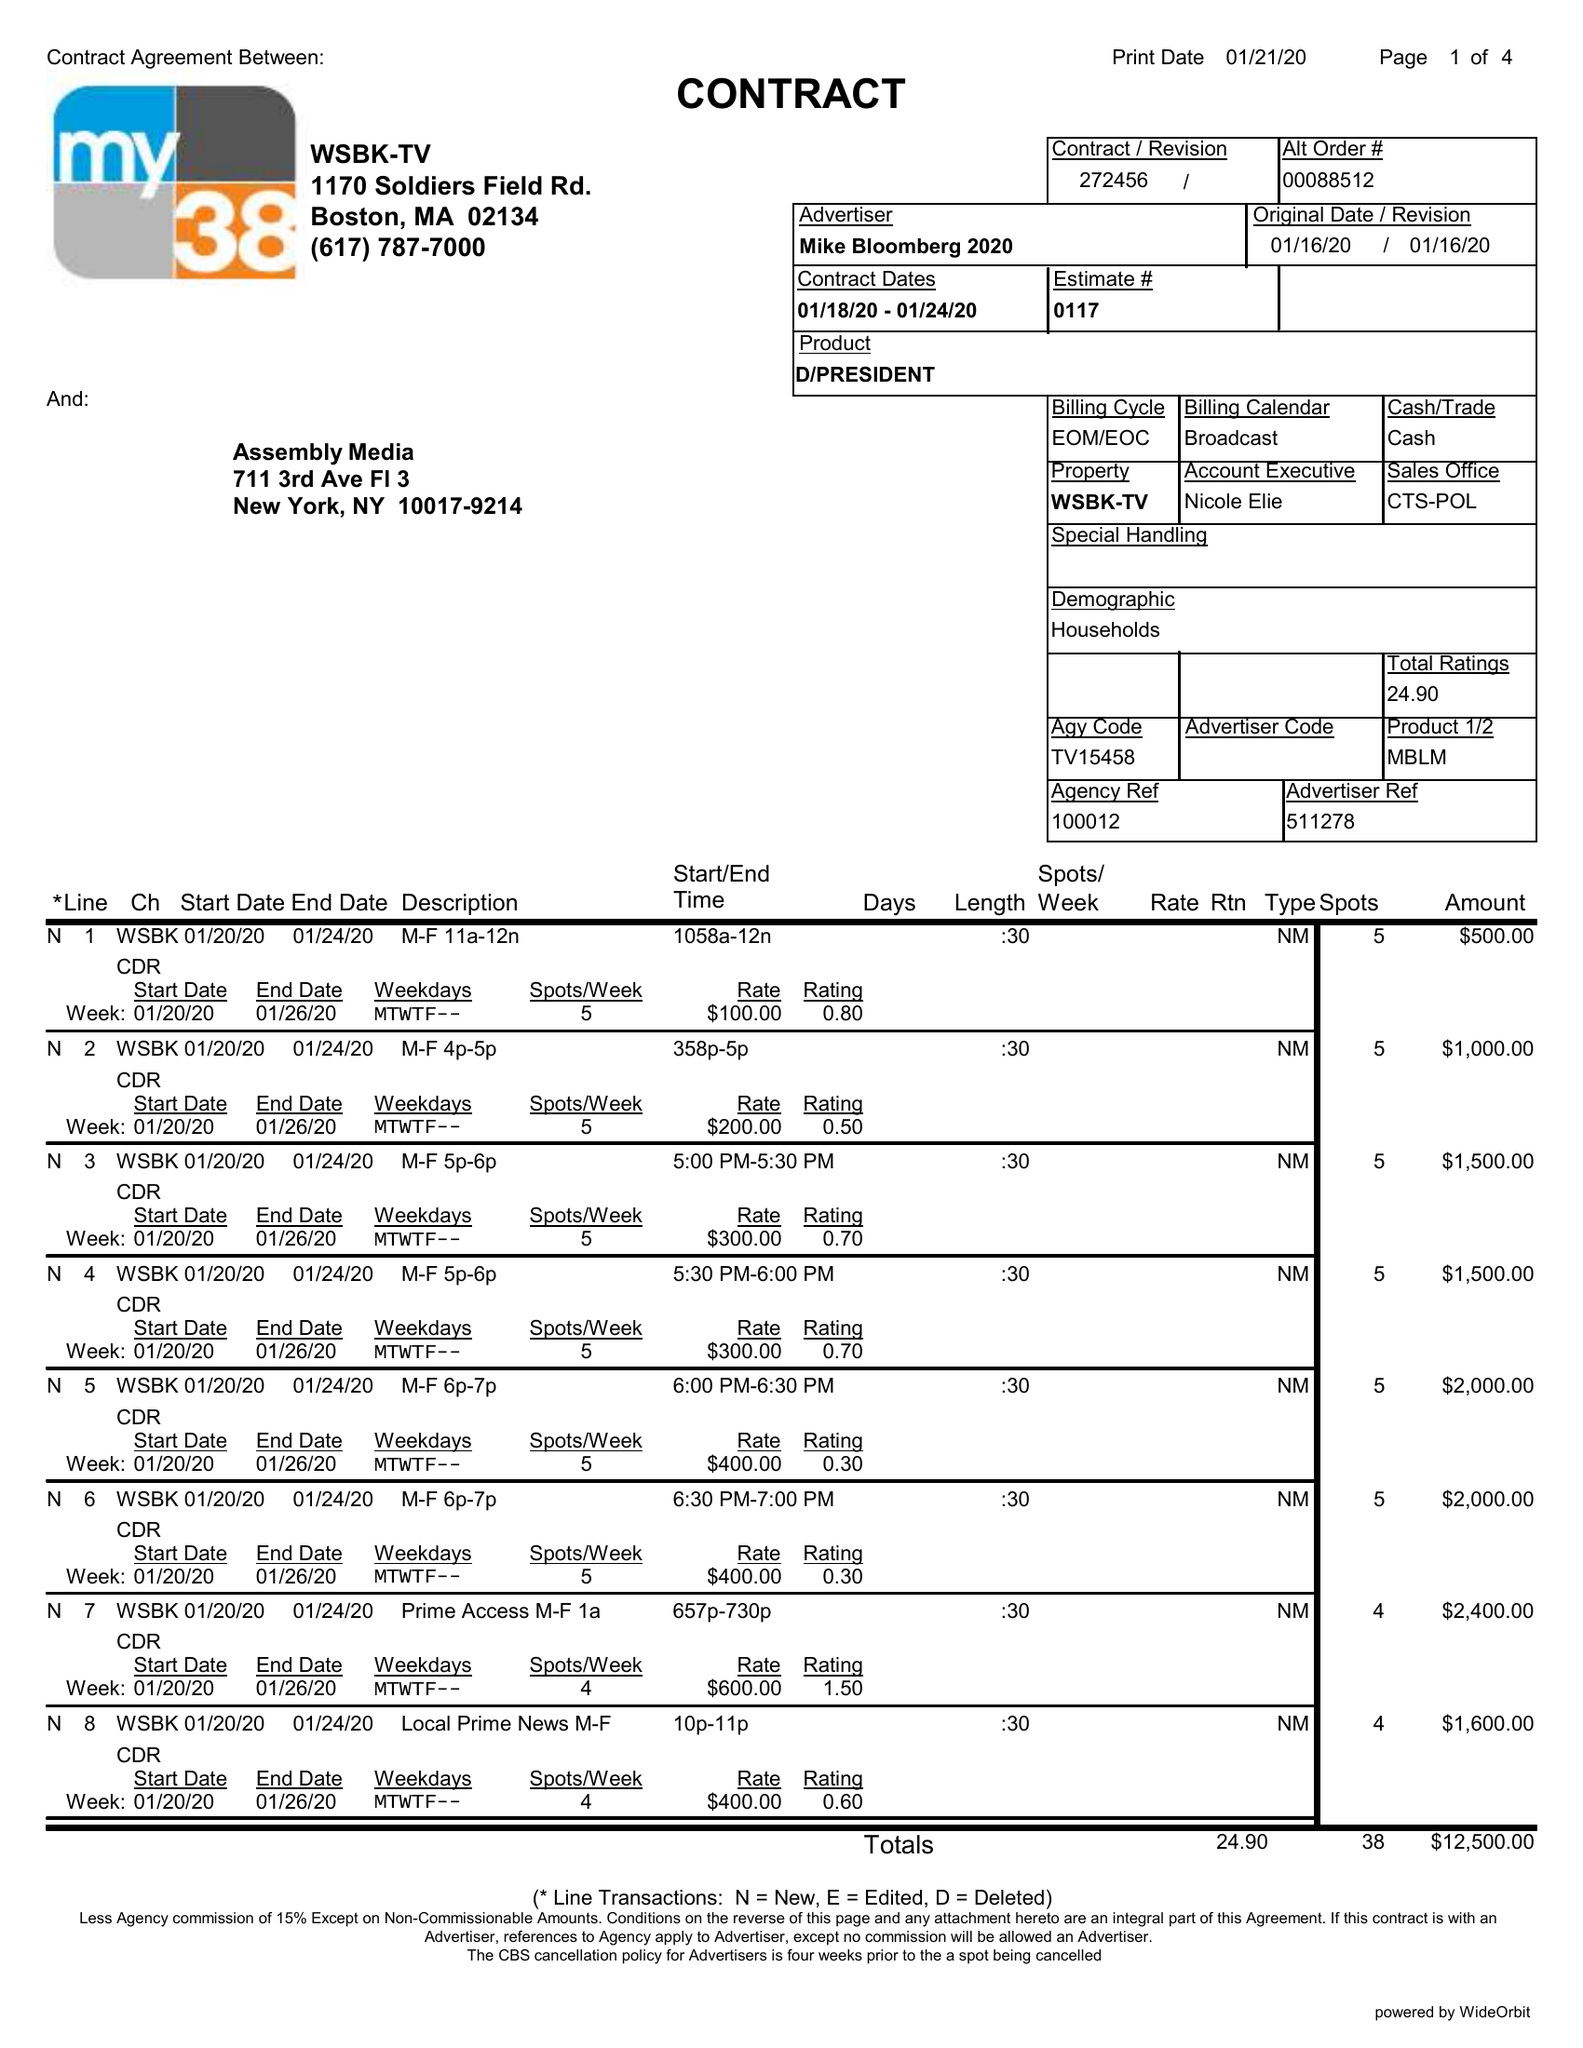What is the value for the advertiser?
Answer the question using a single word or phrase. MIKE BLOOMBERG 2020 